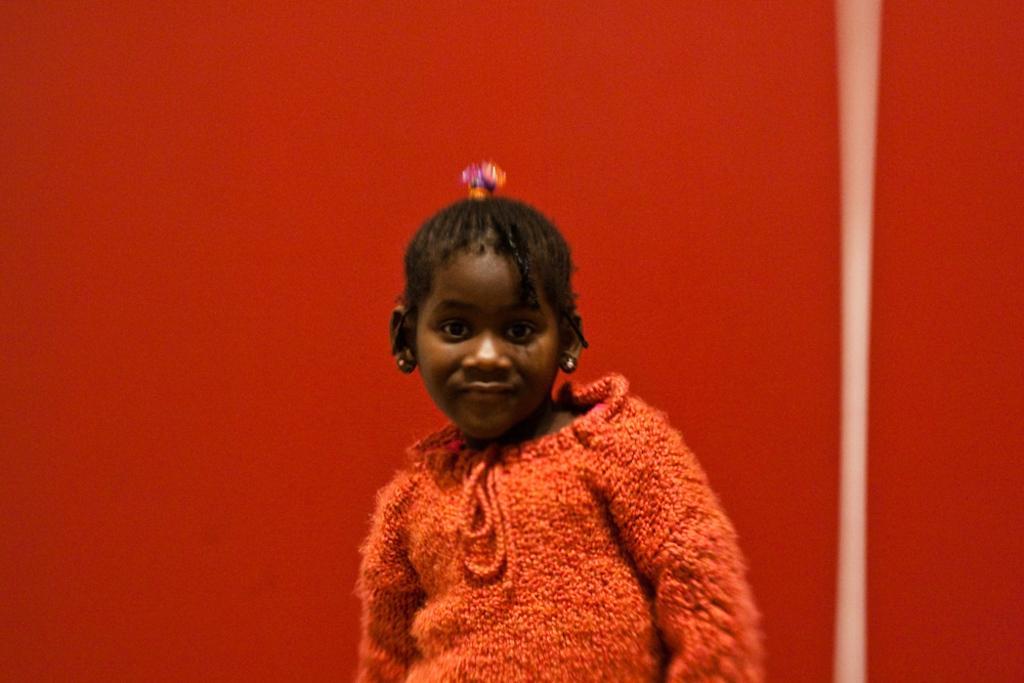How would you summarize this image in a sentence or two? In this picture there is a girl who is wearing red dress. Behind her I can see the red color wall. 